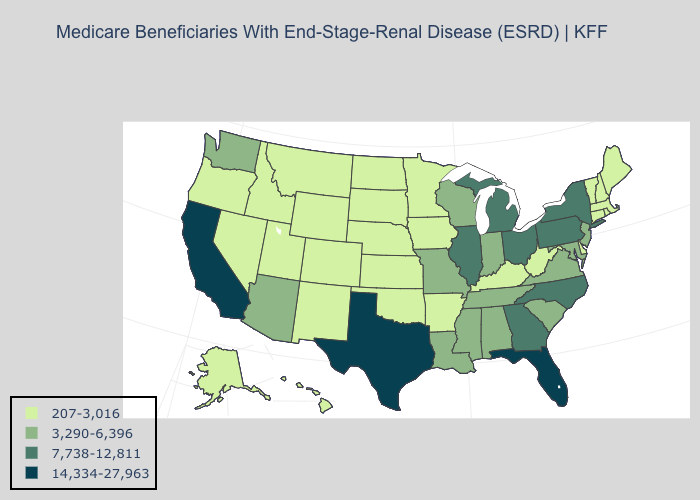Which states have the lowest value in the West?
Give a very brief answer. Alaska, Colorado, Hawaii, Idaho, Montana, Nevada, New Mexico, Oregon, Utah, Wyoming. What is the value of Montana?
Give a very brief answer. 207-3,016. Does the map have missing data?
Short answer required. No. Which states hav the highest value in the South?
Give a very brief answer. Florida, Texas. What is the lowest value in the USA?
Give a very brief answer. 207-3,016. Among the states that border Maryland , does Pennsylvania have the highest value?
Write a very short answer. Yes. Does Florida have the highest value in the USA?
Be succinct. Yes. What is the value of Nevada?
Concise answer only. 207-3,016. Name the states that have a value in the range 207-3,016?
Keep it brief. Alaska, Arkansas, Colorado, Connecticut, Delaware, Hawaii, Idaho, Iowa, Kansas, Kentucky, Maine, Massachusetts, Minnesota, Montana, Nebraska, Nevada, New Hampshire, New Mexico, North Dakota, Oklahoma, Oregon, Rhode Island, South Dakota, Utah, Vermont, West Virginia, Wyoming. Does California have the highest value in the USA?
Give a very brief answer. Yes. What is the lowest value in the MidWest?
Quick response, please. 207-3,016. Does Hawaii have the highest value in the West?
Keep it brief. No. What is the value of Delaware?
Answer briefly. 207-3,016. Among the states that border Florida , does Alabama have the lowest value?
Keep it brief. Yes. Name the states that have a value in the range 14,334-27,963?
Keep it brief. California, Florida, Texas. 